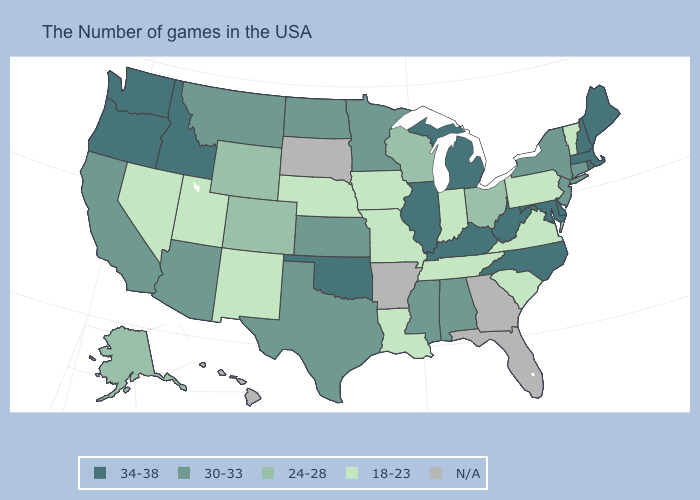Is the legend a continuous bar?
Short answer required. No. Which states hav the highest value in the West?
Be succinct. Idaho, Washington, Oregon. What is the lowest value in the USA?
Short answer required. 18-23. Does Iowa have the highest value in the MidWest?
Answer briefly. No. Which states have the highest value in the USA?
Quick response, please. Maine, Massachusetts, Rhode Island, New Hampshire, Delaware, Maryland, North Carolina, West Virginia, Michigan, Kentucky, Illinois, Oklahoma, Idaho, Washington, Oregon. Which states have the highest value in the USA?
Write a very short answer. Maine, Massachusetts, Rhode Island, New Hampshire, Delaware, Maryland, North Carolina, West Virginia, Michigan, Kentucky, Illinois, Oklahoma, Idaho, Washington, Oregon. What is the value of Virginia?
Quick response, please. 18-23. What is the highest value in the Northeast ?
Be succinct. 34-38. Does Nevada have the lowest value in the USA?
Quick response, please. Yes. Name the states that have a value in the range N/A?
Keep it brief. Florida, Georgia, Arkansas, South Dakota, Hawaii. What is the value of Wyoming?
Be succinct. 24-28. What is the highest value in the USA?
Keep it brief. 34-38. Among the states that border Oregon , which have the lowest value?
Answer briefly. Nevada. Does the first symbol in the legend represent the smallest category?
Keep it brief. No. 